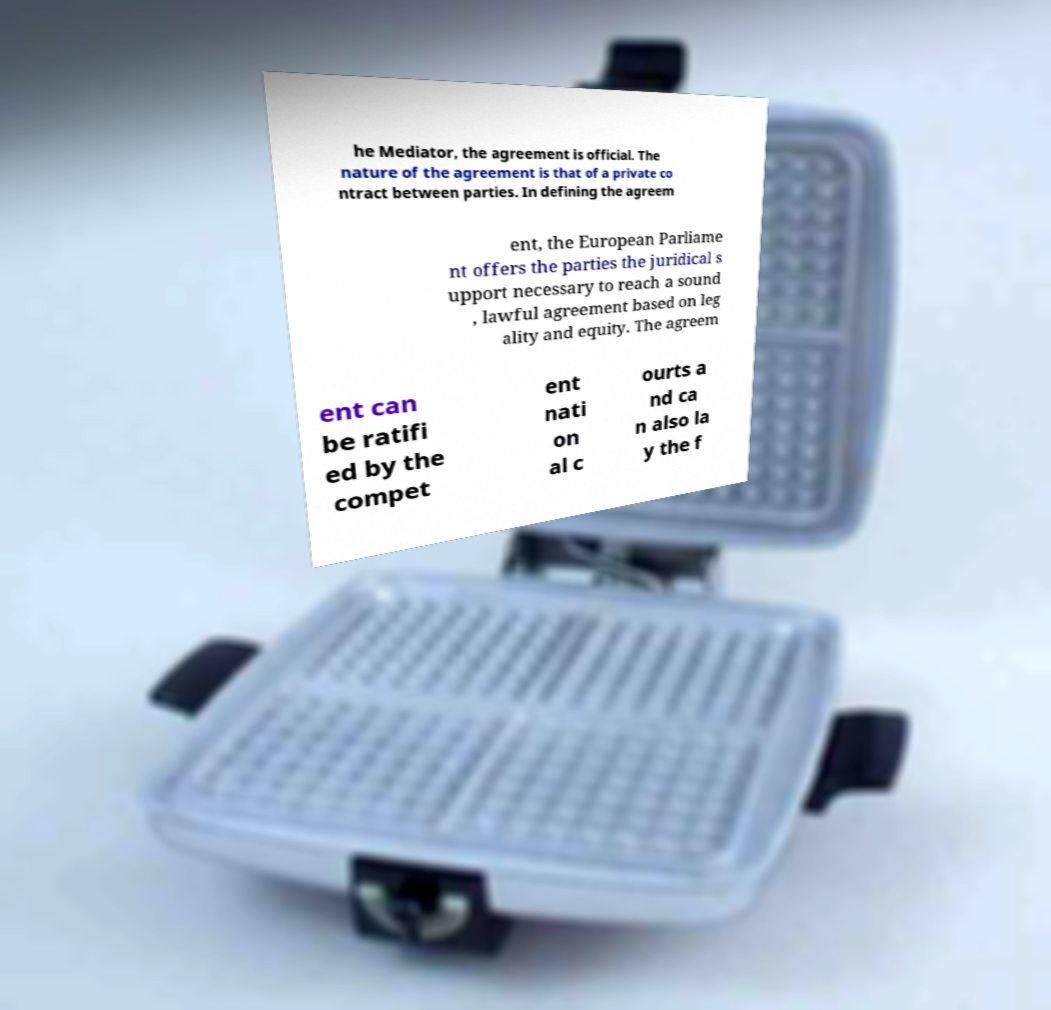Could you extract and type out the text from this image? he Mediator, the agreement is official. The nature of the agreement is that of a private co ntract between parties. In defining the agreem ent, the European Parliame nt offers the parties the juridical s upport necessary to reach a sound , lawful agreement based on leg ality and equity. The agreem ent can be ratifi ed by the compet ent nati on al c ourts a nd ca n also la y the f 